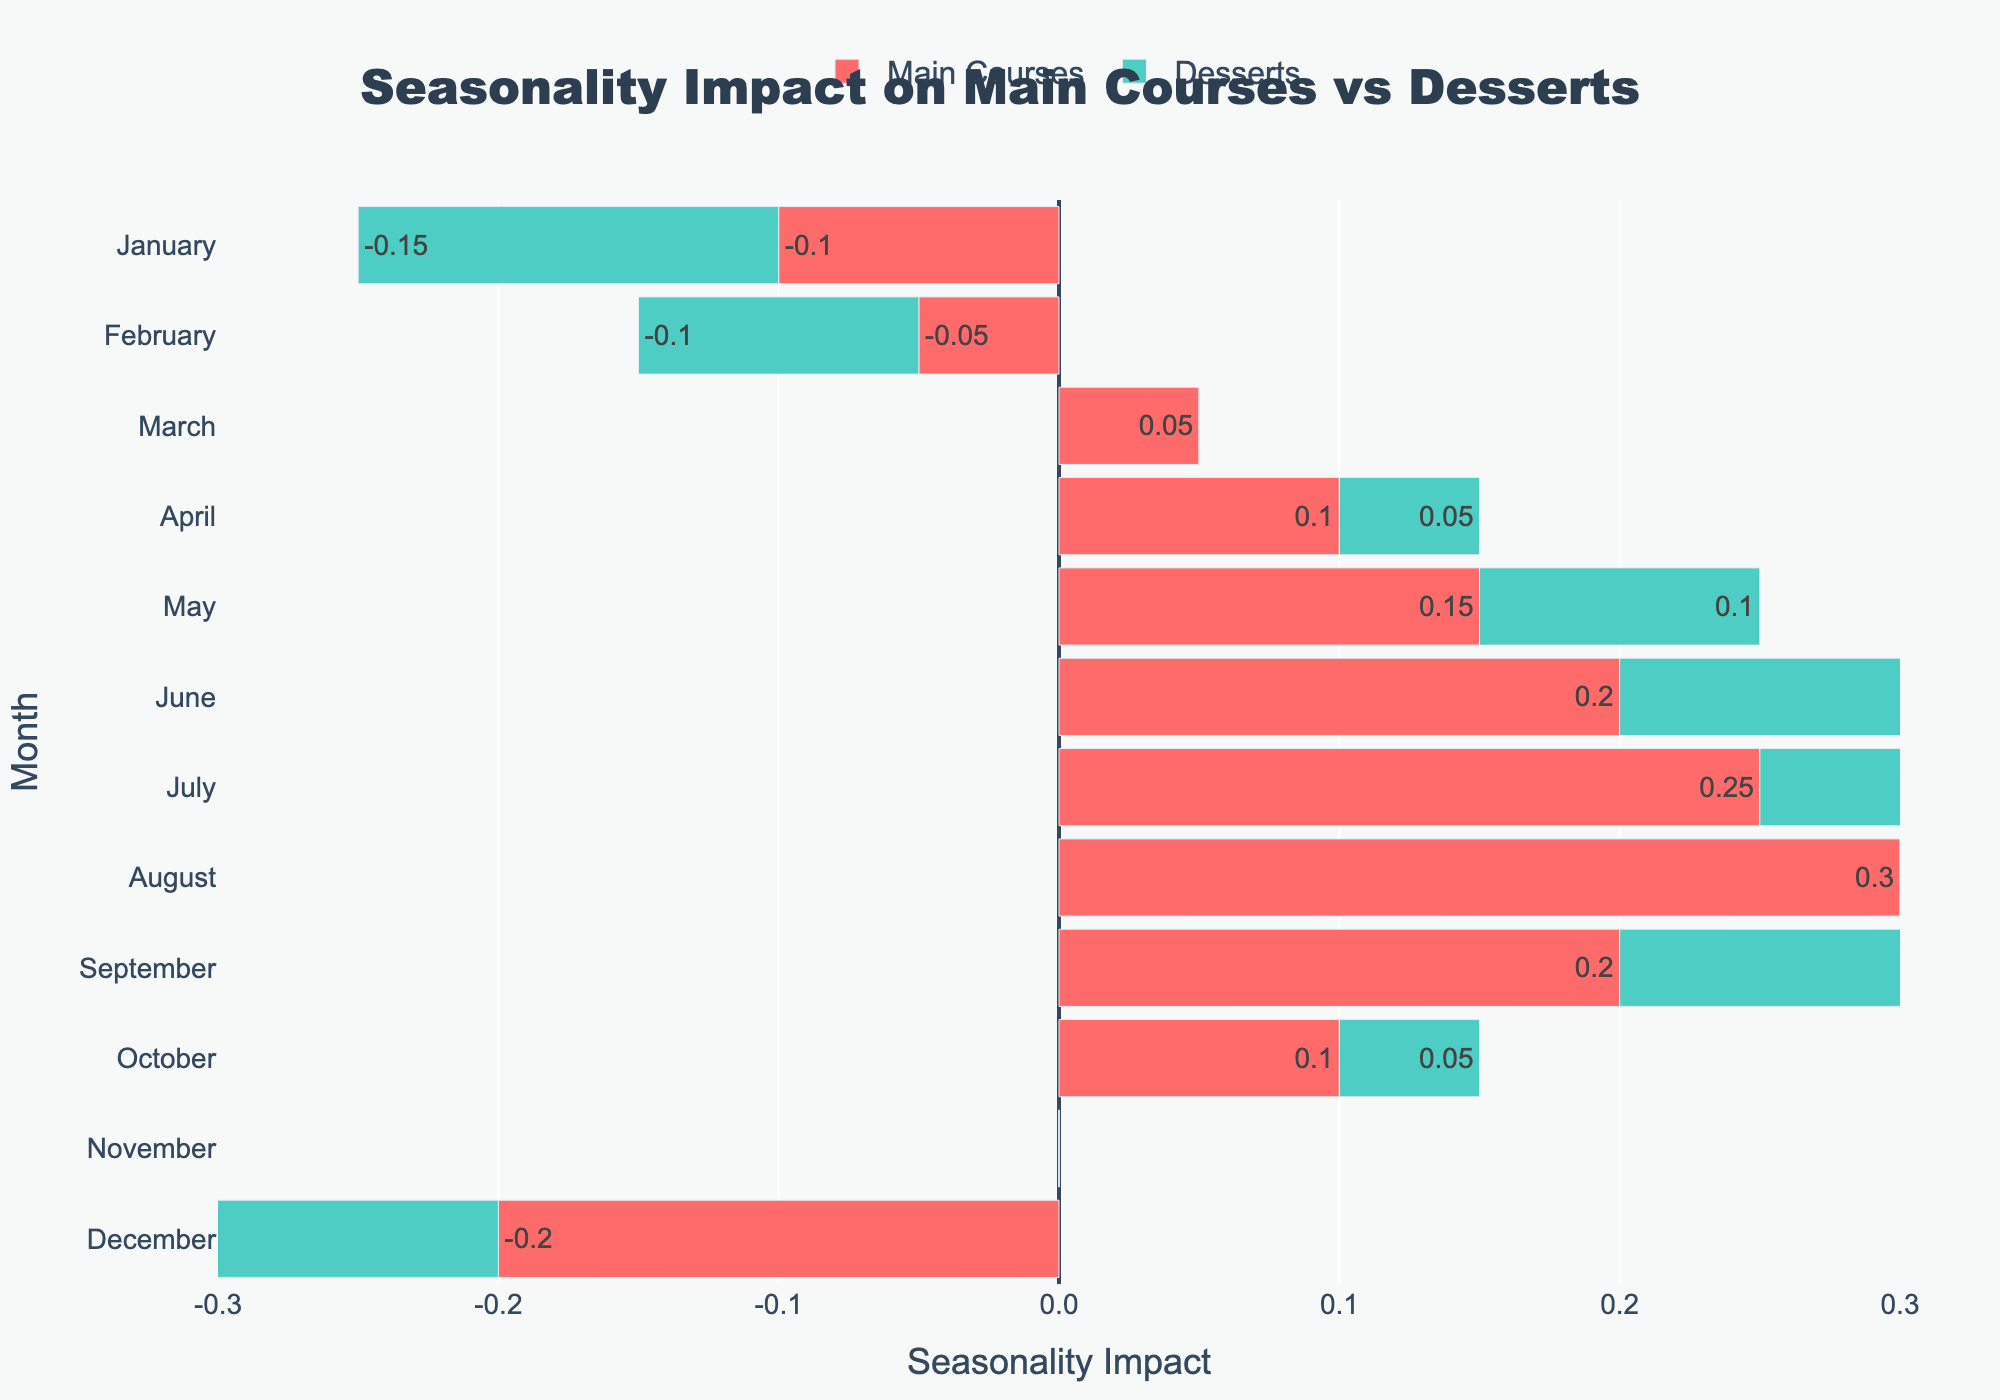What's the seasonality impact difference between main courses and desserts in July? The seasonality impact for main courses in July is 0.25 and for desserts is 0.2. The difference is calculated by subtracting the dessert impact from the main course impact: 0.25 - 0.2 = 0.05
Answer: 0.05 In which month is the positive seasonality impact the highest for main courses? By comparing the positive impacts across all months, we see that August has the highest value with a seasonality impact of 0.3 for main courses.
Answer: August How does the seasonality impact for desserts in February compare to December? The seasonality impact in February for desserts is -0.1, whereas in December, it is -0.2. Comparing these values, February has a higher (less negative) seasonality impact than December.
Answer: February has a higher impact Which month shows the least negative seasonality impact for desserts? By comparing the negative impacts, January has the least negative impact for desserts with a value of -0.15.
Answer: January Which category (main courses or desserts) has the greater overall seasonality impact in April? In April, the seasonality impact for main courses is 0.1 and for desserts is 0.05. Hence, main courses have a greater seasonality impact.
Answer: Main courses How does the visual height of the bars for desserts in March and May compare? In March, the dessert's seasonality impact is 0.0, and in May, it is 0.1. The bar for March is shorter (zero height) in green compared to May.
Answer: May bar is taller What is the average seasonality impact for main courses from January to December? To obtain the average, sum all the impacts for main courses and divide by the number of months: (-0.1 + -0.05 + 0.05 + 0.1 + 0.15 + 0.2 + 0.25 + 0.3 + 0.2 + 0.1 + 0.0 + -0.2) = 1.0. The average is 1.0 / 12 ≈ 0.083.
Answer: 0.083 Which month has equal seasonality impacts for both main courses and desserts? In November, the seasonality impact for both main courses and desserts is 0.0, indicating equality.
Answer: November 